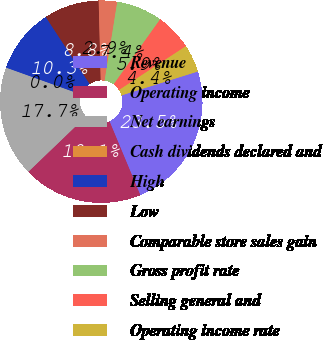<chart> <loc_0><loc_0><loc_500><loc_500><pie_chart><fcel>Revenue<fcel>Operating income<fcel>Net earnings<fcel>Cash dividends declared and<fcel>High<fcel>Low<fcel>Comparable store sales gain<fcel>Gross profit rate<fcel>Selling general and<fcel>Operating income rate<nl><fcel>23.53%<fcel>19.12%<fcel>17.65%<fcel>0.0%<fcel>10.29%<fcel>8.82%<fcel>2.94%<fcel>7.35%<fcel>5.88%<fcel>4.41%<nl></chart> 